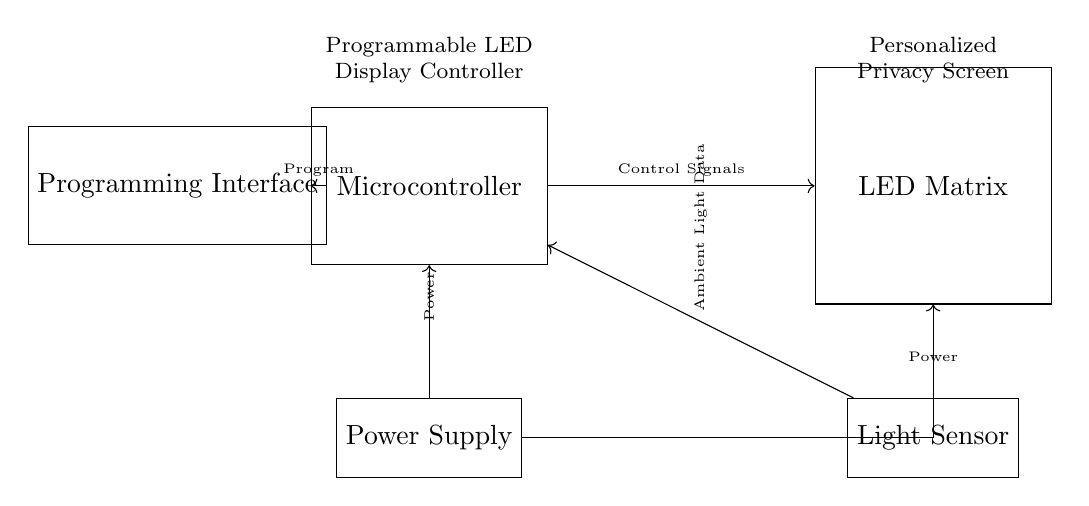What components are present in the circuit diagram? The circuit diagram illustrates three main components: a microcontroller, an LED matrix, and a programming interface, alongside a power supply and a light sensor.
Answer: microcontroller, LED matrix, programming interface, power supply, light sensor What signals does the microcontroller send to the LED matrix? The microcontroller sends control signals to the LED matrix, indicating what patterns or brightness levels should be displayed. The connection arrow denotes this flow of information.
Answer: Control Signals How is the microcontroller powered in this circuit? The power supply connects directly to the microcontroller, which is indicated by the arrow pointing from the power supply to the microcontroller labeled "Power".
Answer: Power What type of data does the light sensor provide to the microcontroller? The light sensor provides ambient light data to the microcontroller, which can be used to adjust the LED display based on the surrounding light levels, as indicated by the connection labeled "Ambient Light Data".
Answer: Ambient Light Data What is the purpose of the programming interface in this circuit? The programming interface allows the user to upload or change the program that controls the microcontroller, enabling customization of how the LED matrix behaves. This is shown by the arrow labeled "Program" going from the programming interface to the microcontroller.
Answer: Program How does the power supply connect to the LED matrix? The power supply connects to the LED matrix through a branching connection from the microcontroller, which also receives power, as indicated by the schematic. The connection is represented by an arrow leading from the power supply for clarity.
Answer: Power 